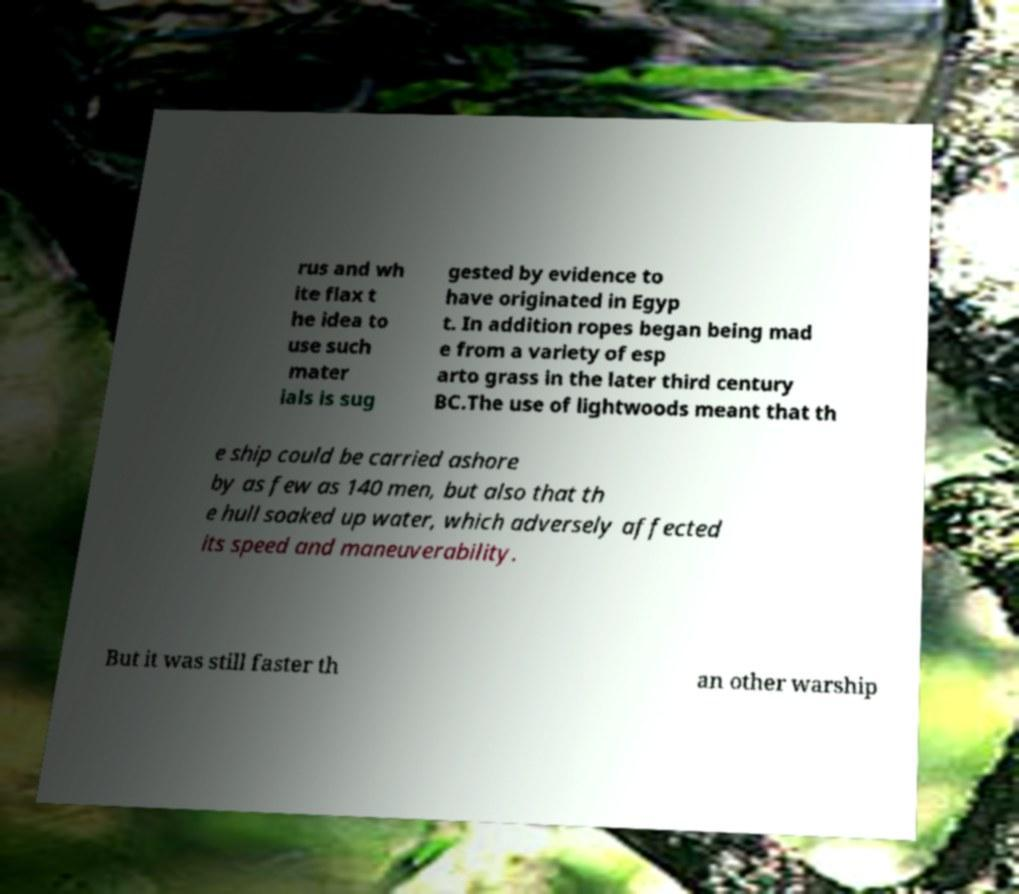Please identify and transcribe the text found in this image. rus and wh ite flax t he idea to use such mater ials is sug gested by evidence to have originated in Egyp t. In addition ropes began being mad e from a variety of esp arto grass in the later third century BC.The use of lightwoods meant that th e ship could be carried ashore by as few as 140 men, but also that th e hull soaked up water, which adversely affected its speed and maneuverability. But it was still faster th an other warship 